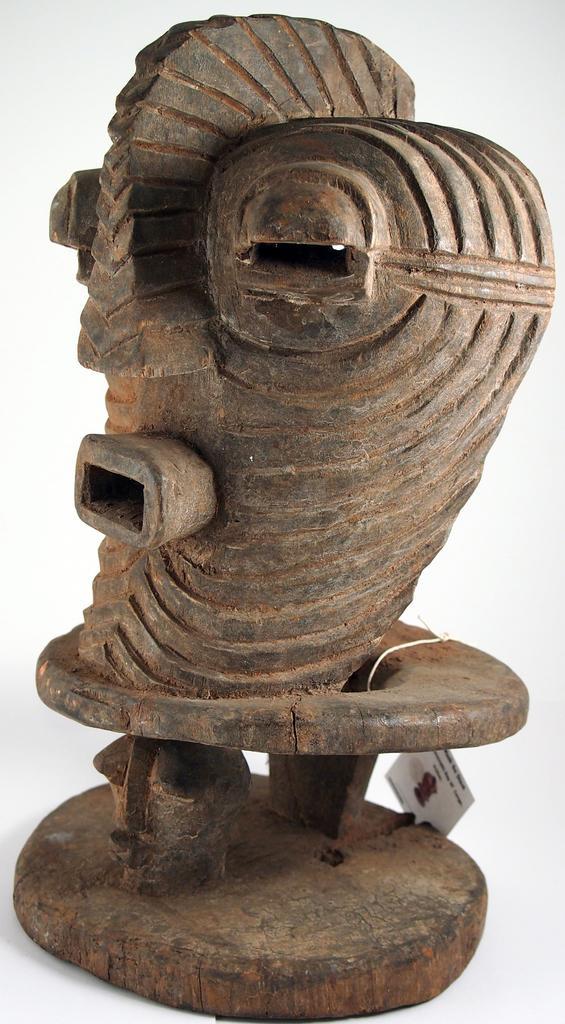Please provide a concise description of this image. In this image we can see a sculpture, there is a card tied to it with some text and picture on it, the background is white. 